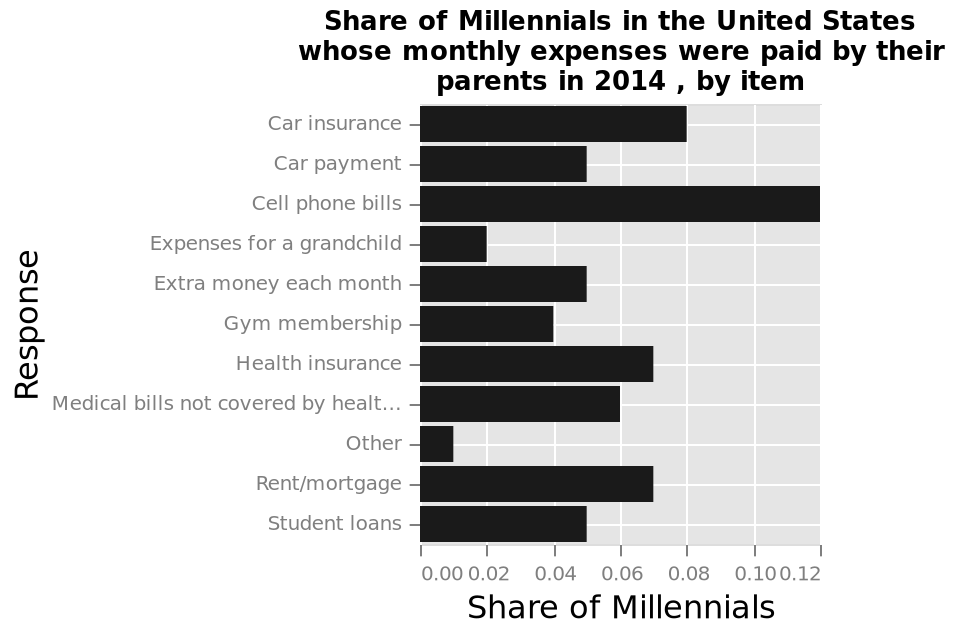<image>
What kind of scale is used on the y-axis? The y-axis uses a categorical scale to represent different types of monthly expenses for Millennials, such as car insurance, student loans, etc. What does the y-axis represent in the bar chart? The y-axis represents different categories of monthly expenses for Millennials, ranging from car insurance to student loans. What percentage of millenials had their parents pay for their cell phone bills?  0.12 millenials had their parents pay for their cell phone bills. 